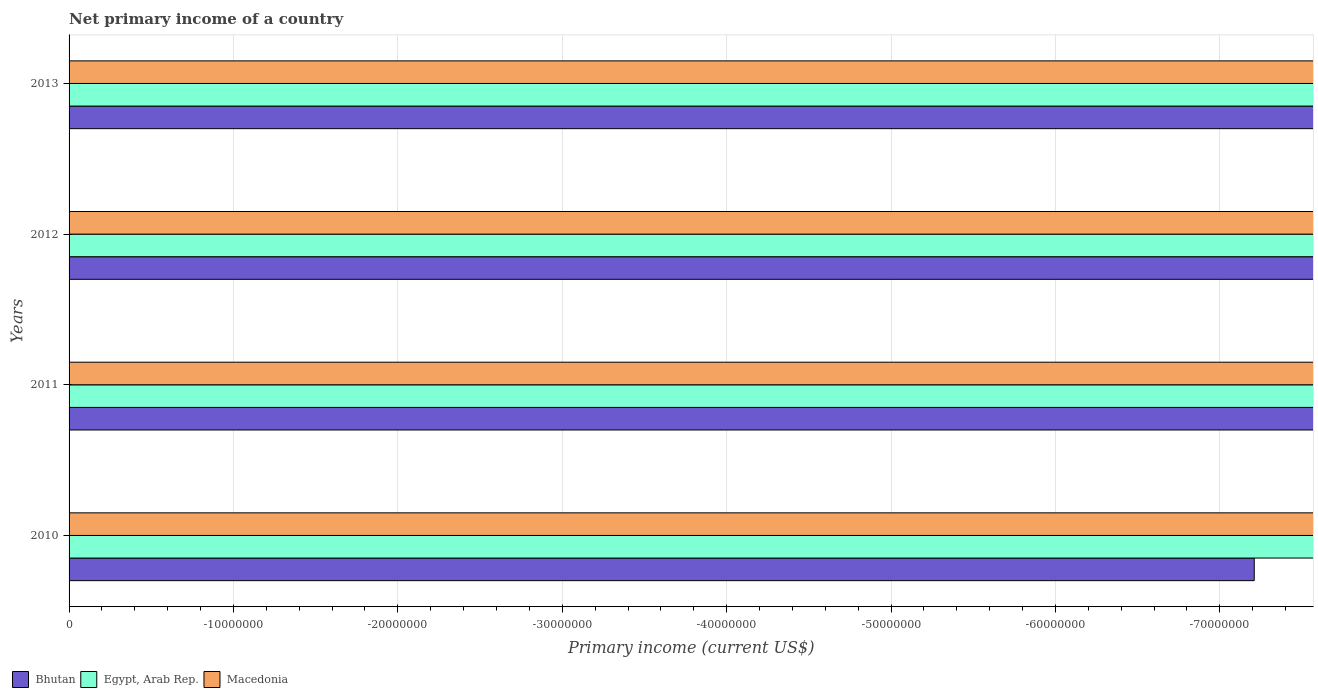How many different coloured bars are there?
Keep it short and to the point. 0. Are the number of bars per tick equal to the number of legend labels?
Provide a succinct answer. No. Are the number of bars on each tick of the Y-axis equal?
Keep it short and to the point. Yes. How many bars are there on the 2nd tick from the top?
Ensure brevity in your answer.  0. What is the label of the 4th group of bars from the top?
Provide a succinct answer. 2010. What is the difference between the primary income in Egypt, Arab Rep. in 2013 and the primary income in Bhutan in 2012?
Your answer should be compact. 0. What is the average primary income in Macedonia per year?
Ensure brevity in your answer.  0. In how many years, is the primary income in Macedonia greater than -12000000 US$?
Provide a succinct answer. 0. Is it the case that in every year, the sum of the primary income in Bhutan and primary income in Macedonia is greater than the primary income in Egypt, Arab Rep.?
Provide a succinct answer. No. How many bars are there?
Ensure brevity in your answer.  0. What is the difference between two consecutive major ticks on the X-axis?
Your answer should be very brief. 1.00e+07. Does the graph contain grids?
Make the answer very short. Yes. How are the legend labels stacked?
Your answer should be very brief. Horizontal. What is the title of the graph?
Your response must be concise. Net primary income of a country. Does "Tunisia" appear as one of the legend labels in the graph?
Keep it short and to the point. No. What is the label or title of the X-axis?
Keep it short and to the point. Primary income (current US$). What is the Primary income (current US$) of Egypt, Arab Rep. in 2010?
Your answer should be compact. 0. What is the Primary income (current US$) of Bhutan in 2011?
Ensure brevity in your answer.  0. What is the Primary income (current US$) of Egypt, Arab Rep. in 2012?
Your answer should be compact. 0. What is the Primary income (current US$) in Bhutan in 2013?
Keep it short and to the point. 0. What is the Primary income (current US$) of Macedonia in 2013?
Provide a short and direct response. 0. What is the total Primary income (current US$) in Bhutan in the graph?
Make the answer very short. 0. What is the average Primary income (current US$) of Bhutan per year?
Make the answer very short. 0. What is the average Primary income (current US$) in Egypt, Arab Rep. per year?
Your answer should be compact. 0. What is the average Primary income (current US$) of Macedonia per year?
Your answer should be compact. 0. 